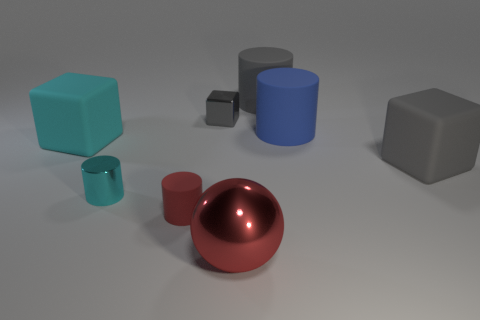What is the color of the tiny shiny object that is behind the rubber object on the left side of the small cyan metal cylinder?
Offer a very short reply. Gray. Are there any spheres of the same color as the small rubber cylinder?
Provide a short and direct response. Yes. What size is the cylinder that is in front of the small thing left of the red thing that is on the left side of the big metal ball?
Keep it short and to the point. Small. Is the shape of the red rubber thing the same as the large rubber object behind the tiny gray metallic block?
Your answer should be compact. Yes. How many other things are there of the same size as the red ball?
Make the answer very short. 4. What size is the matte cube that is to the left of the big red metal thing?
Your answer should be very brief. Large. How many gray things are made of the same material as the ball?
Provide a succinct answer. 1. There is a small thing that is on the right side of the tiny red matte cylinder; is its shape the same as the large cyan thing?
Your answer should be very brief. Yes. There is a large rubber thing on the left side of the big red ball; what shape is it?
Provide a short and direct response. Cube. There is a rubber cylinder that is the same color as the metal cube; what size is it?
Provide a succinct answer. Large. 